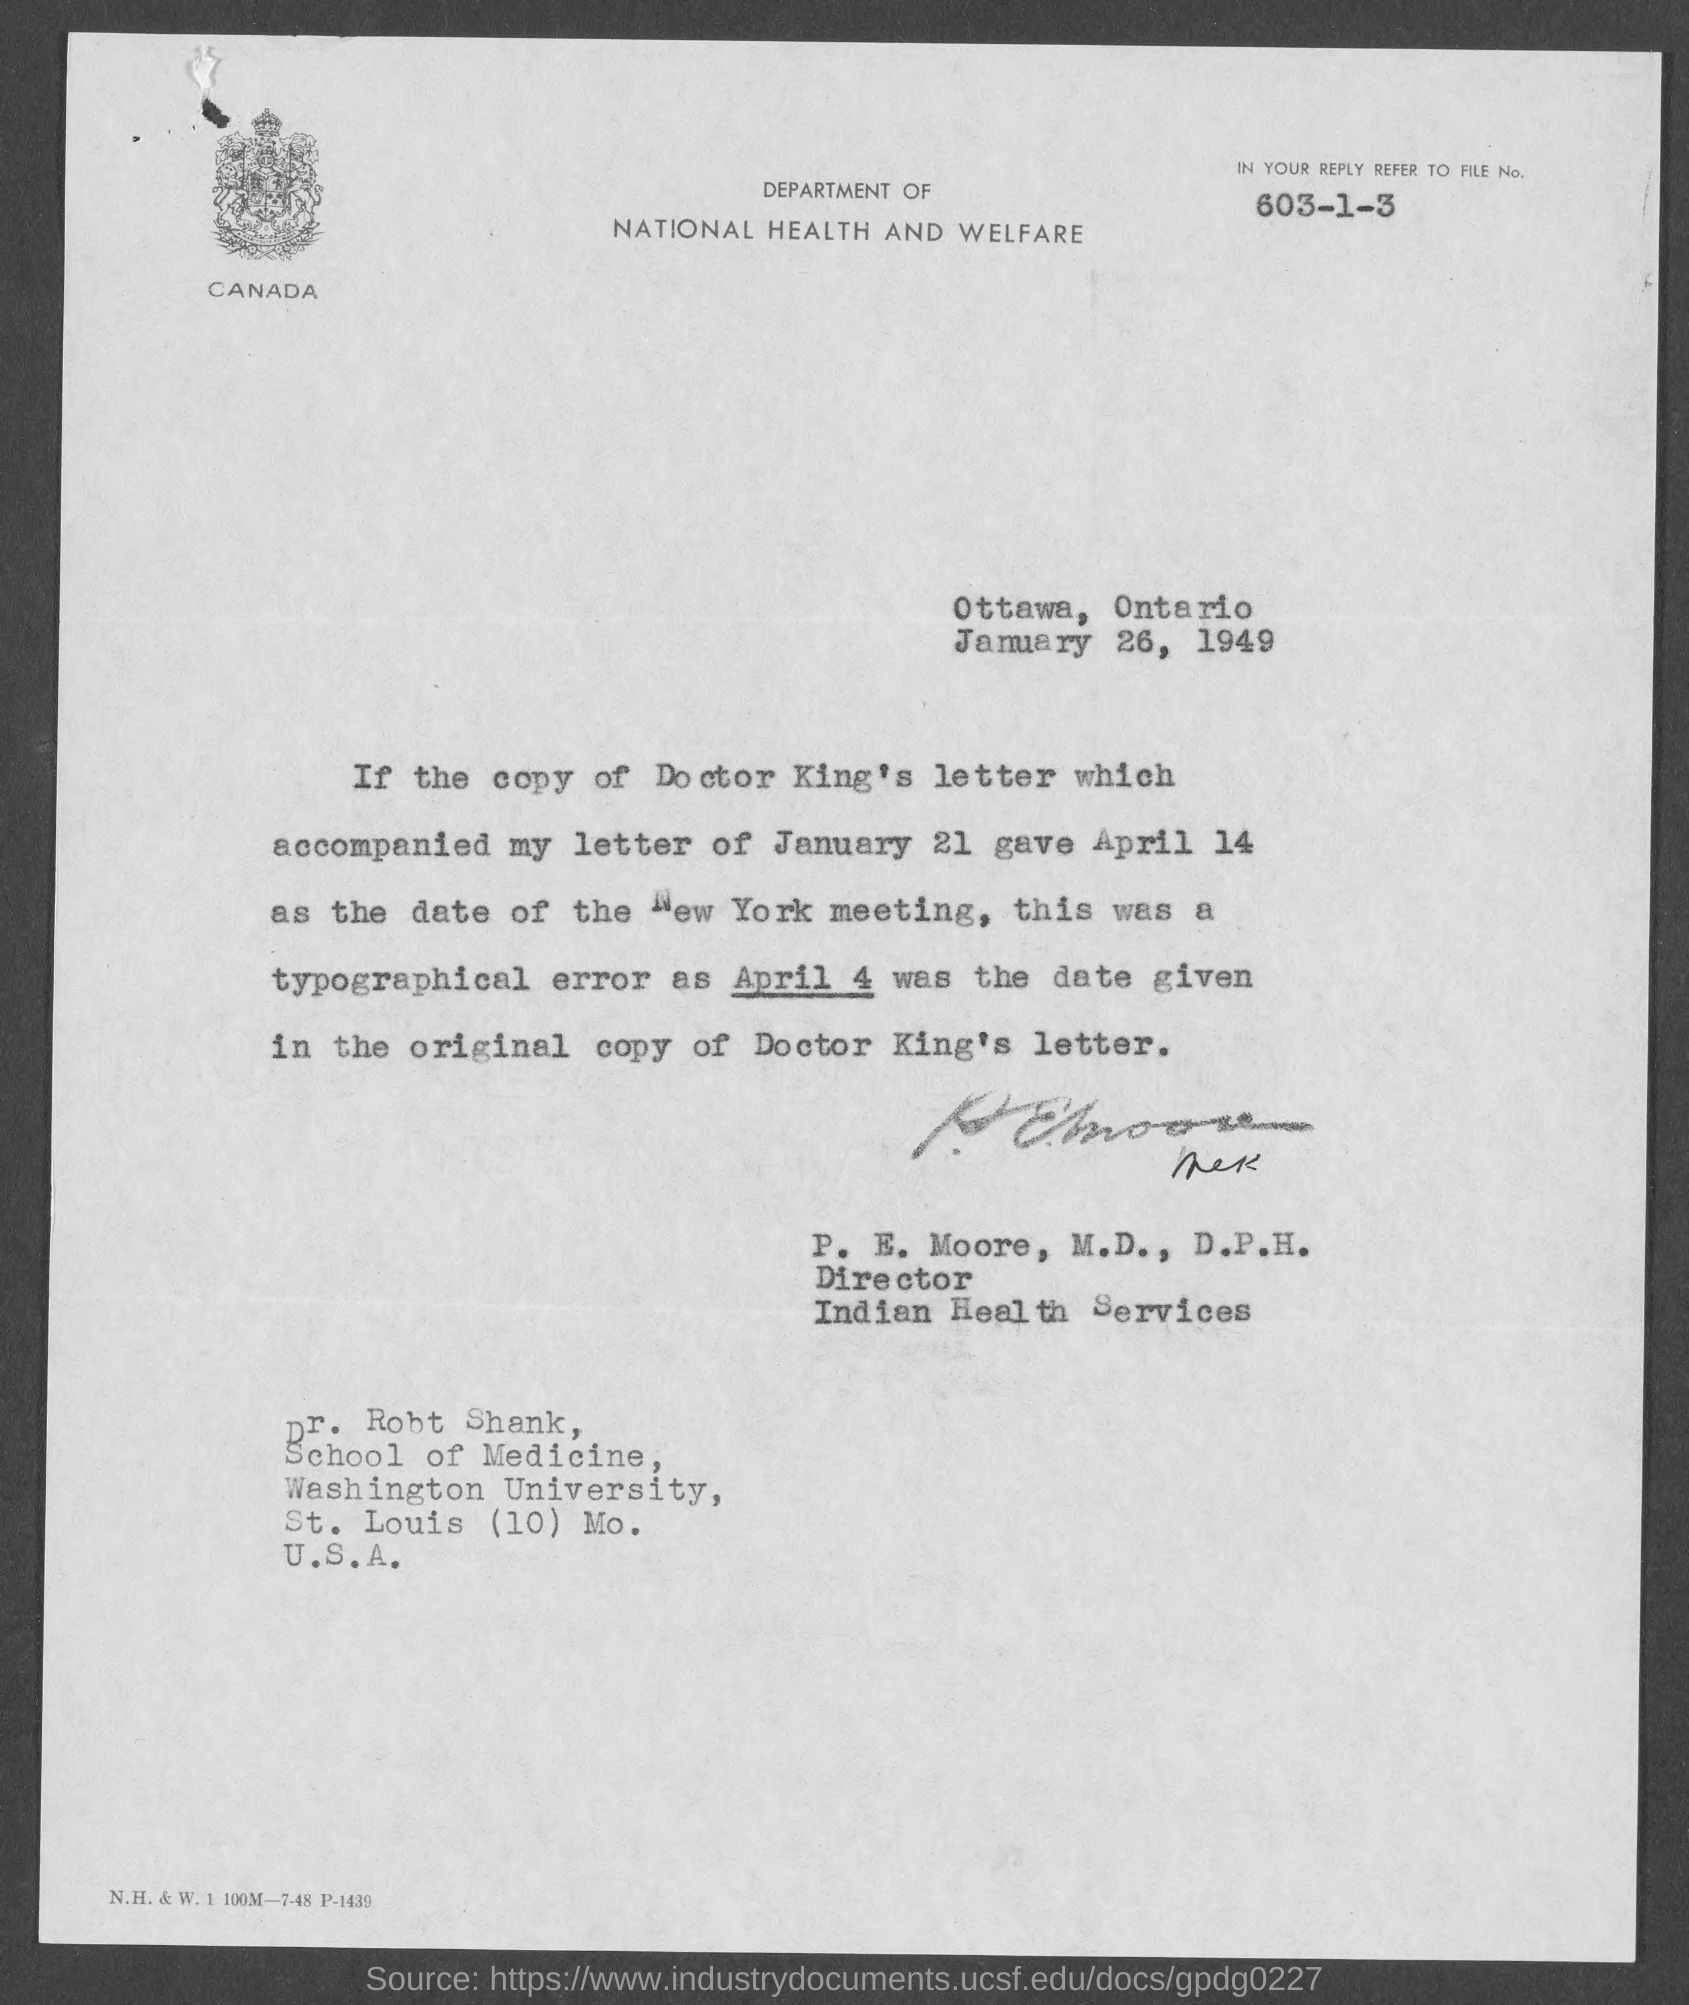Specify some key components in this picture. The Director of Indian Health Services is P.E. Moore, M.D., D.P.H. The place from which the letter is written is Ottawa, Ontario. File number 603-1-3 must be referred to. The date on which the letter is dated is January 26, 1949. 